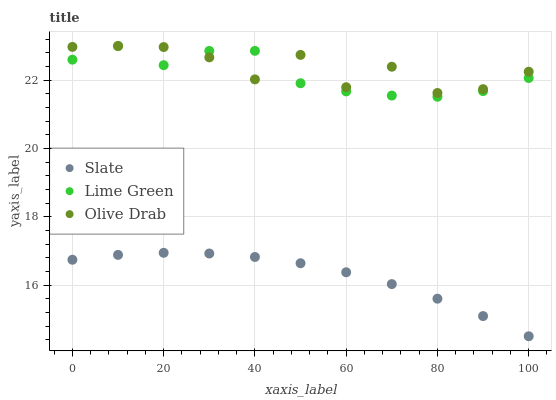Does Slate have the minimum area under the curve?
Answer yes or no. Yes. Does Olive Drab have the maximum area under the curve?
Answer yes or no. Yes. Does Lime Green have the minimum area under the curve?
Answer yes or no. No. Does Lime Green have the maximum area under the curve?
Answer yes or no. No. Is Slate the smoothest?
Answer yes or no. Yes. Is Olive Drab the roughest?
Answer yes or no. Yes. Is Lime Green the smoothest?
Answer yes or no. No. Is Lime Green the roughest?
Answer yes or no. No. Does Slate have the lowest value?
Answer yes or no. Yes. Does Lime Green have the lowest value?
Answer yes or no. No. Does Olive Drab have the highest value?
Answer yes or no. Yes. Is Slate less than Lime Green?
Answer yes or no. Yes. Is Olive Drab greater than Slate?
Answer yes or no. Yes. Does Lime Green intersect Olive Drab?
Answer yes or no. Yes. Is Lime Green less than Olive Drab?
Answer yes or no. No. Is Lime Green greater than Olive Drab?
Answer yes or no. No. Does Slate intersect Lime Green?
Answer yes or no. No. 